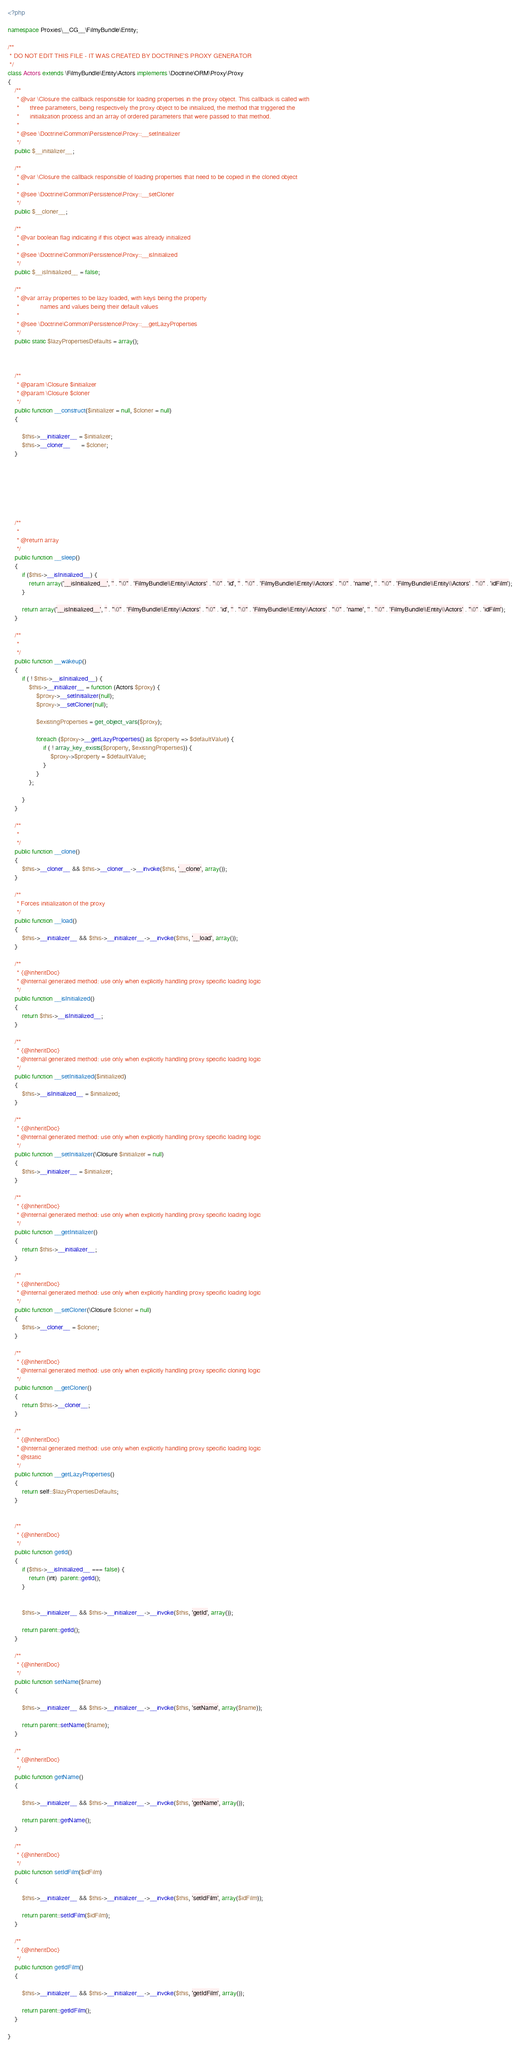Convert code to text. <code><loc_0><loc_0><loc_500><loc_500><_PHP_><?php

namespace Proxies\__CG__\FilmyBundle\Entity;

/**
 * DO NOT EDIT THIS FILE - IT WAS CREATED BY DOCTRINE'S PROXY GENERATOR
 */
class Actors extends \FilmyBundle\Entity\Actors implements \Doctrine\ORM\Proxy\Proxy
{
    /**
     * @var \Closure the callback responsible for loading properties in the proxy object. This callback is called with
     *      three parameters, being respectively the proxy object to be initialized, the method that triggered the
     *      initialization process and an array of ordered parameters that were passed to that method.
     *
     * @see \Doctrine\Common\Persistence\Proxy::__setInitializer
     */
    public $__initializer__;

    /**
     * @var \Closure the callback responsible of loading properties that need to be copied in the cloned object
     *
     * @see \Doctrine\Common\Persistence\Proxy::__setCloner
     */
    public $__cloner__;

    /**
     * @var boolean flag indicating if this object was already initialized
     *
     * @see \Doctrine\Common\Persistence\Proxy::__isInitialized
     */
    public $__isInitialized__ = false;

    /**
     * @var array properties to be lazy loaded, with keys being the property
     *            names and values being their default values
     *
     * @see \Doctrine\Common\Persistence\Proxy::__getLazyProperties
     */
    public static $lazyPropertiesDefaults = array();



    /**
     * @param \Closure $initializer
     * @param \Closure $cloner
     */
    public function __construct($initializer = null, $cloner = null)
    {

        $this->__initializer__ = $initializer;
        $this->__cloner__      = $cloner;
    }







    /**
     * 
     * @return array
     */
    public function __sleep()
    {
        if ($this->__isInitialized__) {
            return array('__isInitialized__', '' . "\0" . 'FilmyBundle\\Entity\\Actors' . "\0" . 'id', '' . "\0" . 'FilmyBundle\\Entity\\Actors' . "\0" . 'name', '' . "\0" . 'FilmyBundle\\Entity\\Actors' . "\0" . 'idFilm');
        }

        return array('__isInitialized__', '' . "\0" . 'FilmyBundle\\Entity\\Actors' . "\0" . 'id', '' . "\0" . 'FilmyBundle\\Entity\\Actors' . "\0" . 'name', '' . "\0" . 'FilmyBundle\\Entity\\Actors' . "\0" . 'idFilm');
    }

    /**
     * 
     */
    public function __wakeup()
    {
        if ( ! $this->__isInitialized__) {
            $this->__initializer__ = function (Actors $proxy) {
                $proxy->__setInitializer(null);
                $proxy->__setCloner(null);

                $existingProperties = get_object_vars($proxy);

                foreach ($proxy->__getLazyProperties() as $property => $defaultValue) {
                    if ( ! array_key_exists($property, $existingProperties)) {
                        $proxy->$property = $defaultValue;
                    }
                }
            };

        }
    }

    /**
     * 
     */
    public function __clone()
    {
        $this->__cloner__ && $this->__cloner__->__invoke($this, '__clone', array());
    }

    /**
     * Forces initialization of the proxy
     */
    public function __load()
    {
        $this->__initializer__ && $this->__initializer__->__invoke($this, '__load', array());
    }

    /**
     * {@inheritDoc}
     * @internal generated method: use only when explicitly handling proxy specific loading logic
     */
    public function __isInitialized()
    {
        return $this->__isInitialized__;
    }

    /**
     * {@inheritDoc}
     * @internal generated method: use only when explicitly handling proxy specific loading logic
     */
    public function __setInitialized($initialized)
    {
        $this->__isInitialized__ = $initialized;
    }

    /**
     * {@inheritDoc}
     * @internal generated method: use only when explicitly handling proxy specific loading logic
     */
    public function __setInitializer(\Closure $initializer = null)
    {
        $this->__initializer__ = $initializer;
    }

    /**
     * {@inheritDoc}
     * @internal generated method: use only when explicitly handling proxy specific loading logic
     */
    public function __getInitializer()
    {
        return $this->__initializer__;
    }

    /**
     * {@inheritDoc}
     * @internal generated method: use only when explicitly handling proxy specific loading logic
     */
    public function __setCloner(\Closure $cloner = null)
    {
        $this->__cloner__ = $cloner;
    }

    /**
     * {@inheritDoc}
     * @internal generated method: use only when explicitly handling proxy specific cloning logic
     */
    public function __getCloner()
    {
        return $this->__cloner__;
    }

    /**
     * {@inheritDoc}
     * @internal generated method: use only when explicitly handling proxy specific loading logic
     * @static
     */
    public function __getLazyProperties()
    {
        return self::$lazyPropertiesDefaults;
    }

    
    /**
     * {@inheritDoc}
     */
    public function getId()
    {
        if ($this->__isInitialized__ === false) {
            return (int)  parent::getId();
        }


        $this->__initializer__ && $this->__initializer__->__invoke($this, 'getId', array());

        return parent::getId();
    }

    /**
     * {@inheritDoc}
     */
    public function setName($name)
    {

        $this->__initializer__ && $this->__initializer__->__invoke($this, 'setName', array($name));

        return parent::setName($name);
    }

    /**
     * {@inheritDoc}
     */
    public function getName()
    {

        $this->__initializer__ && $this->__initializer__->__invoke($this, 'getName', array());

        return parent::getName();
    }

    /**
     * {@inheritDoc}
     */
    public function setIdFilm($idFilm)
    {

        $this->__initializer__ && $this->__initializer__->__invoke($this, 'setIdFilm', array($idFilm));

        return parent::setIdFilm($idFilm);
    }

    /**
     * {@inheritDoc}
     */
    public function getIdFilm()
    {

        $this->__initializer__ && $this->__initializer__->__invoke($this, 'getIdFilm', array());

        return parent::getIdFilm();
    }

}
</code> 